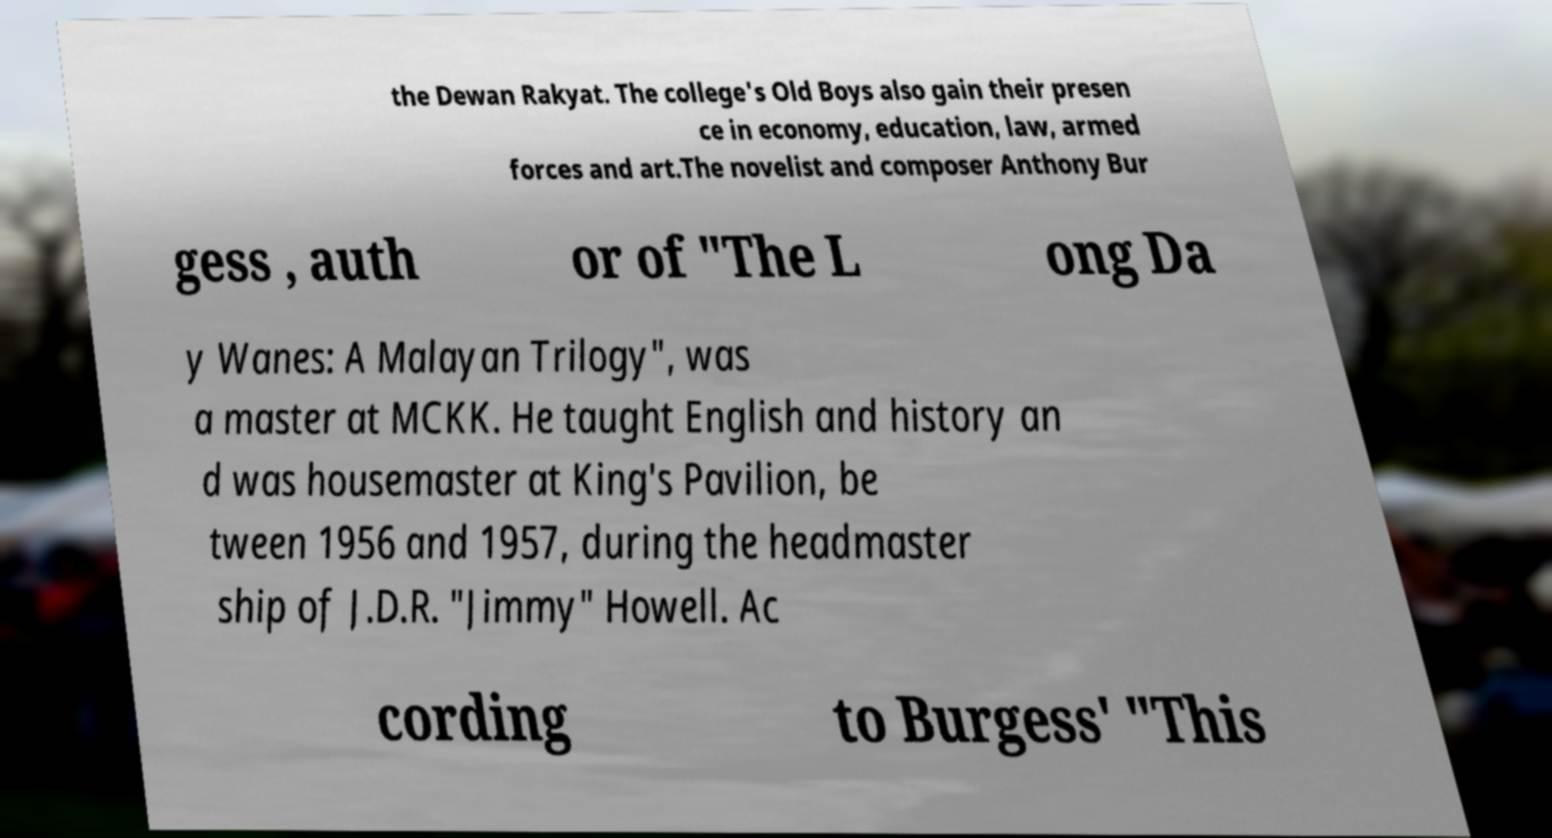Please read and relay the text visible in this image. What does it say? the Dewan Rakyat. The college's Old Boys also gain their presen ce in economy, education, law, armed forces and art.The novelist and composer Anthony Bur gess , auth or of "The L ong Da y Wanes: A Malayan Trilogy", was a master at MCKK. He taught English and history an d was housemaster at King's Pavilion, be tween 1956 and 1957, during the headmaster ship of J.D.R. "Jimmy" Howell. Ac cording to Burgess' "This 